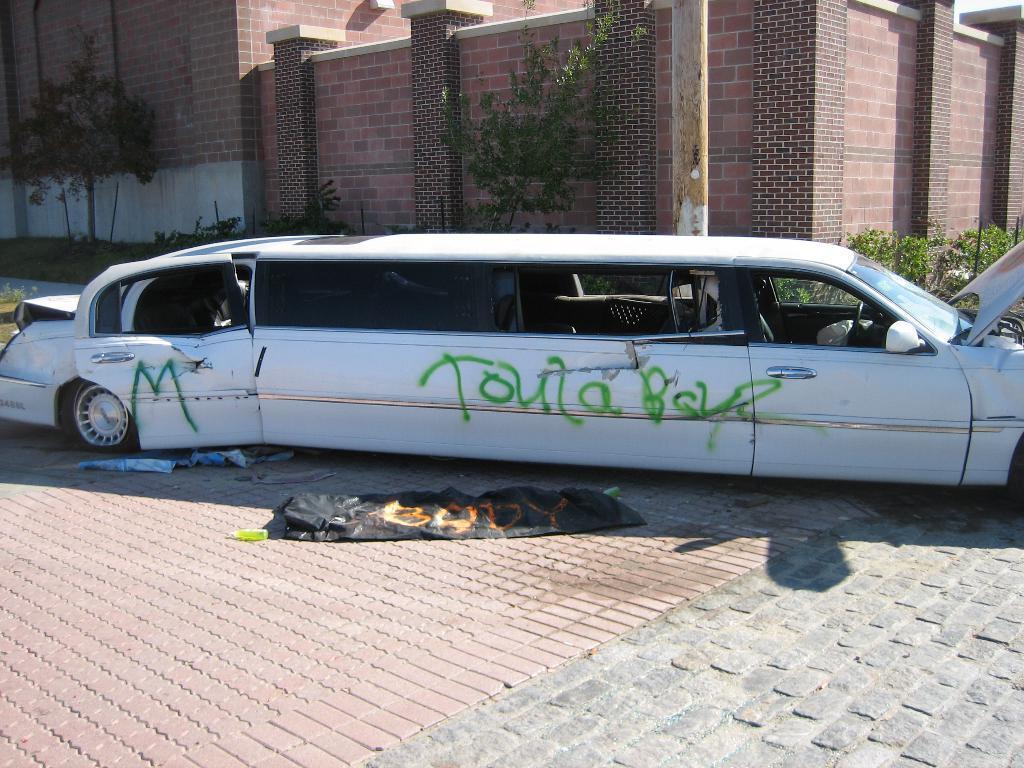Please provide a concise description of this image. In this image there is a Limousin on the road. In the background there are plants and buildings. At the bottom of the image there are banners on the road. 